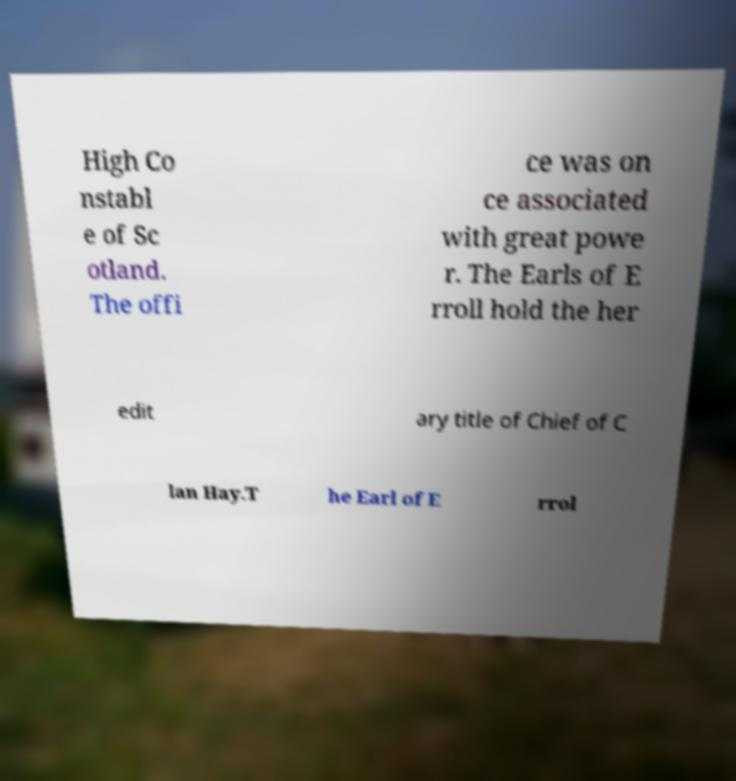Could you assist in decoding the text presented in this image and type it out clearly? High Co nstabl e of Sc otland. The offi ce was on ce associated with great powe r. The Earls of E rroll hold the her edit ary title of Chief of C lan Hay.T he Earl of E rrol 